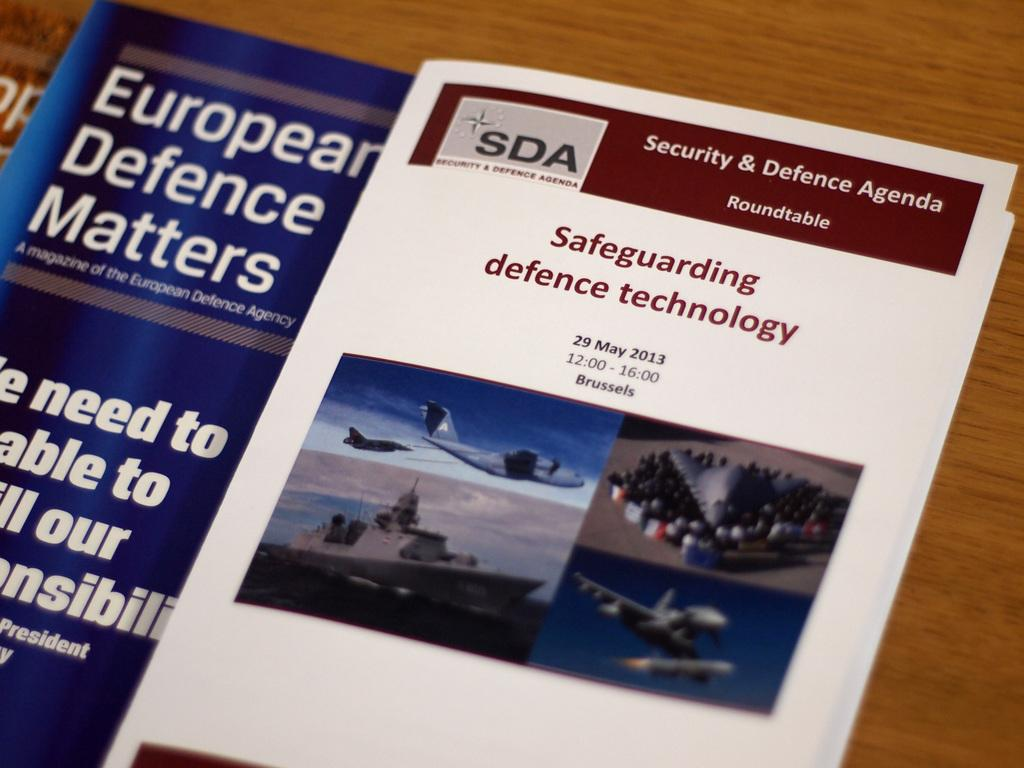<image>
Relay a brief, clear account of the picture shown. A pamphlet about Safeguarding Defence Technology sits on a wooden surface. 